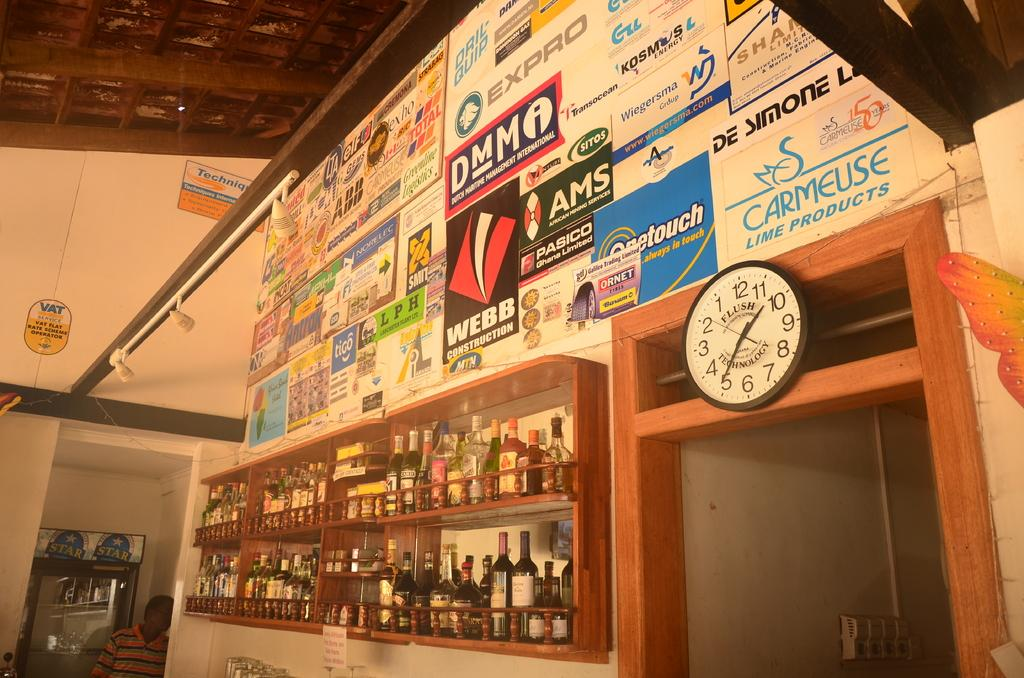What objects are arranged on shelves in the image? There are bottles arranged on shelves in the image. What type of decorations are present in the image? There are posters in the image. What time-telling device is visible in the image? There is a clock in the image. What type of frames are present in the image? There are frames in the image. Can you describe the person in the image? There is a person in the image. What type of shoe is being used to create the posters in the image? There is no shoe present in the image, nor is there any indication that the posters are being created in the image. Can you tell me who the creator of the frames is in the image? There is no information about the creator of the frames in the image. 